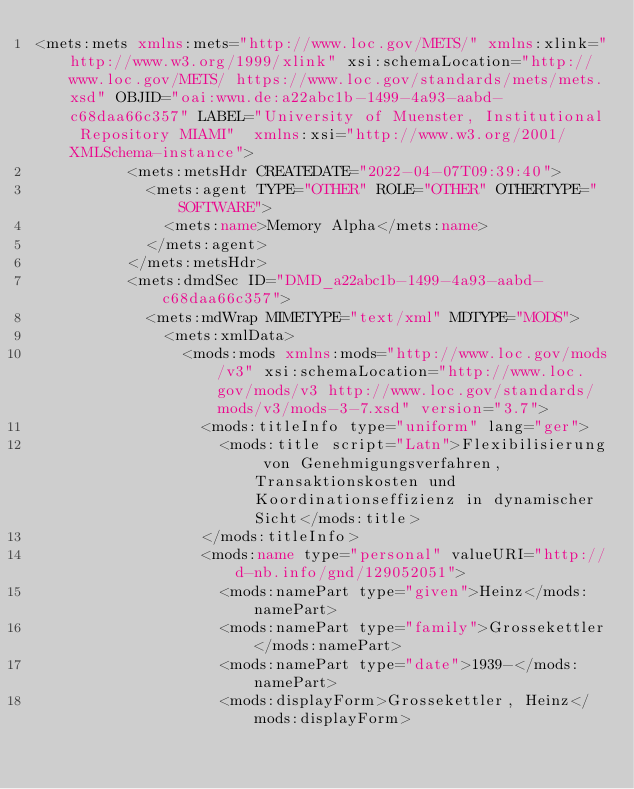<code> <loc_0><loc_0><loc_500><loc_500><_XML_><mets:mets xmlns:mets="http://www.loc.gov/METS/" xmlns:xlink="http://www.w3.org/1999/xlink" xsi:schemaLocation="http://www.loc.gov/METS/ https://www.loc.gov/standards/mets/mets.xsd" OBJID="oai:wwu.de:a22abc1b-1499-4a93-aabd-c68daa66c357" LABEL="University of Muenster, Institutional Repository MIAMI"  xmlns:xsi="http://www.w3.org/2001/XMLSchema-instance">
          <mets:metsHdr CREATEDATE="2022-04-07T09:39:40">
            <mets:agent TYPE="OTHER" ROLE="OTHER" OTHERTYPE="SOFTWARE">
              <mets:name>Memory Alpha</mets:name>
            </mets:agent>
          </mets:metsHdr>
          <mets:dmdSec ID="DMD_a22abc1b-1499-4a93-aabd-c68daa66c357">
            <mets:mdWrap MIMETYPE="text/xml" MDTYPE="MODS">
              <mets:xmlData>
                <mods:mods xmlns:mods="http://www.loc.gov/mods/v3" xsi:schemaLocation="http://www.loc.gov/mods/v3 http://www.loc.gov/standards/mods/v3/mods-3-7.xsd" version="3.7">
                  <mods:titleInfo type="uniform" lang="ger">
                    <mods:title script="Latn">Flexibilisierung von Genehmigungsverfahren, Transaktionskosten und Koordinationseffizienz in dynamischer Sicht</mods:title>
                  </mods:titleInfo>
                  <mods:name type="personal" valueURI="http://d-nb.info/gnd/129052051">
                    <mods:namePart type="given">Heinz</mods:namePart>
                    <mods:namePart type="family">Grossekettler</mods:namePart>
                    <mods:namePart type="date">1939-</mods:namePart>
                    <mods:displayForm>Grossekettler, Heinz</mods:displayForm></code> 